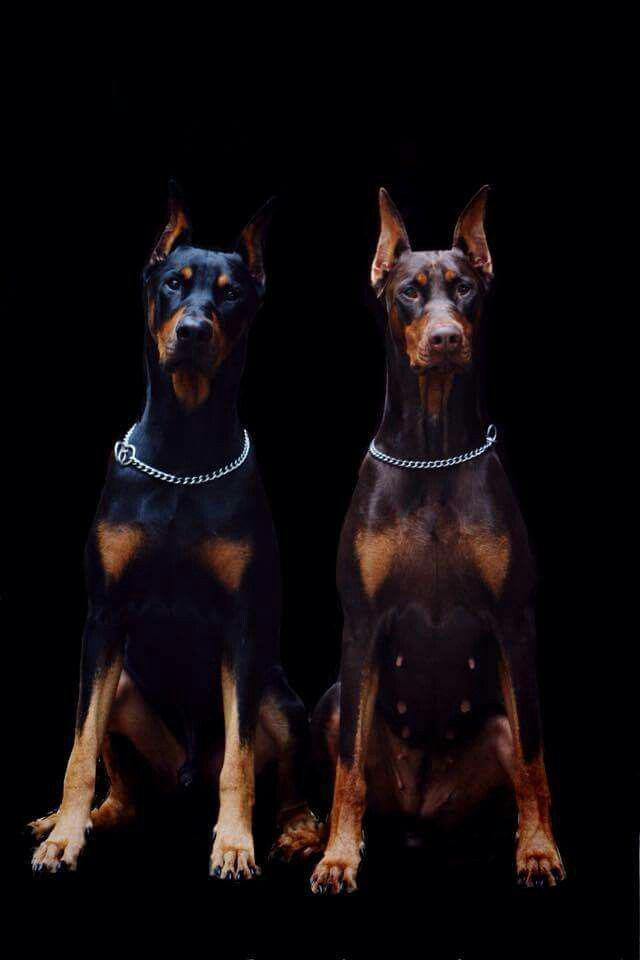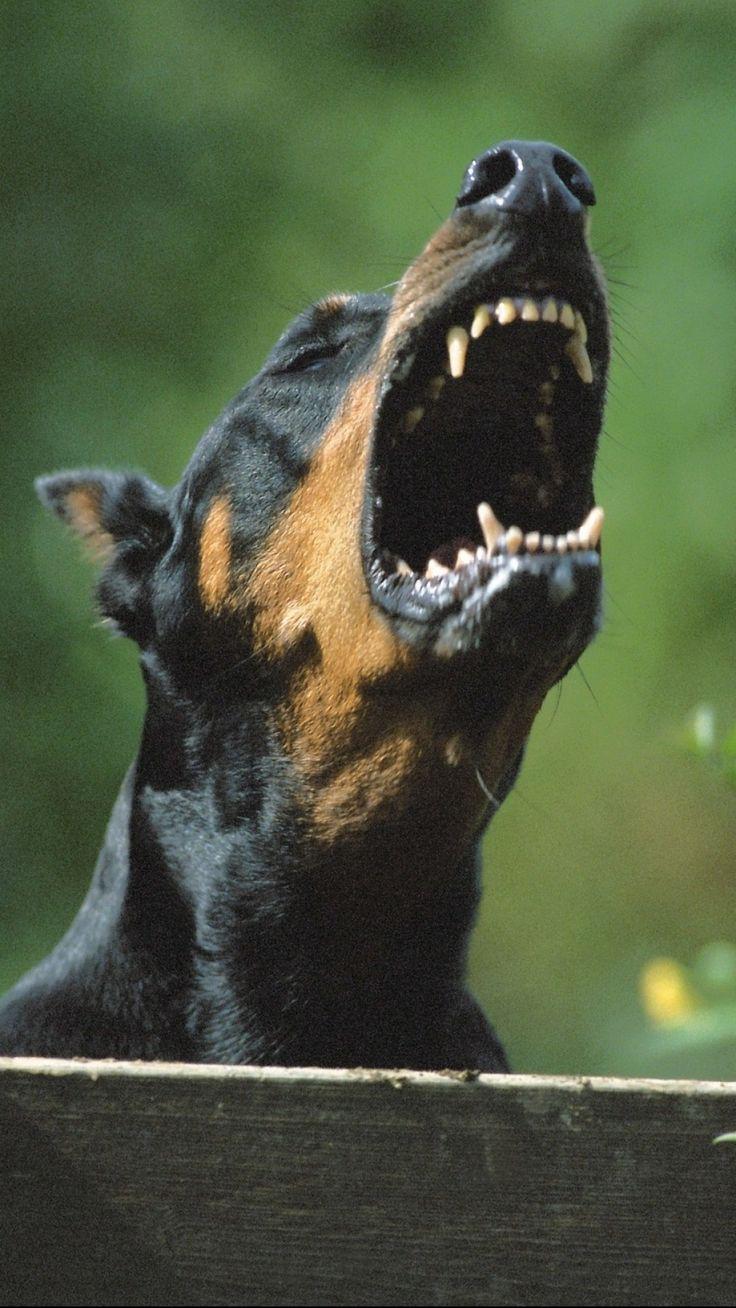The first image is the image on the left, the second image is the image on the right. Examine the images to the left and right. Is the description "The left image contains at least two dogs." accurate? Answer yes or no. Yes. The first image is the image on the left, the second image is the image on the right. For the images shown, is this caption "Each image contains the same number of dogs, at least one of the dogs depicted gazes straight forward, and all dogs are erect-eared doberman." true? Answer yes or no. No. 